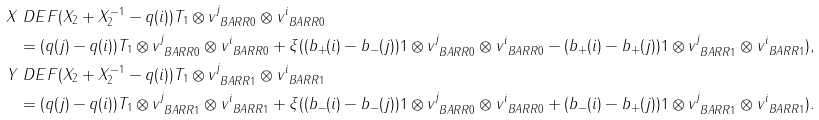<formula> <loc_0><loc_0><loc_500><loc_500>X & \ D E F ( X _ { 2 } + X _ { 2 } ^ { - 1 } - q ( i ) ) T _ { 1 } \otimes v ^ { j } _ { \ B A R R { 0 } } \otimes v ^ { i } _ { \ B A R R { 0 } } \\ & = ( q ( j ) - q ( i ) ) T _ { 1 } \otimes v ^ { j } _ { \ B A R R { 0 } } \otimes v ^ { i } _ { \ B A R R { 0 } } + \xi ( ( b _ { + } ( i ) - b _ { - } ( j ) ) 1 \otimes v ^ { j } _ { \ B A R R { 0 } } \otimes v ^ { i } _ { \ B A R R { 0 } } - ( b _ { + } ( i ) - b _ { + } ( j ) ) 1 \otimes v ^ { j } _ { \ B A R R { 1 } } \otimes v ^ { i } _ { \ B A R R { 1 } } ) , \\ Y & \ D E F ( X _ { 2 } + X _ { 2 } ^ { - 1 } - q ( i ) ) T _ { 1 } \otimes v ^ { j } _ { \ B A R R { 1 } } \otimes v ^ { i } _ { \ B A R R { 1 } } \\ & = ( q ( j ) - q ( i ) ) T _ { 1 } \otimes v ^ { j } _ { \ B A R R { 1 } } \otimes v ^ { i } _ { \ B A R R { 1 } } + \xi ( ( b _ { - } ( i ) - b _ { - } ( j ) ) 1 \otimes v ^ { j } _ { \ B A R R { 0 } } \otimes v ^ { i } _ { \ B A R R { 0 } } + ( b _ { - } ( i ) - b _ { + } ( j ) ) 1 \otimes v ^ { j } _ { \ B A R R { 1 } } \otimes v ^ { i } _ { \ B A R R { 1 } } ) .</formula> 